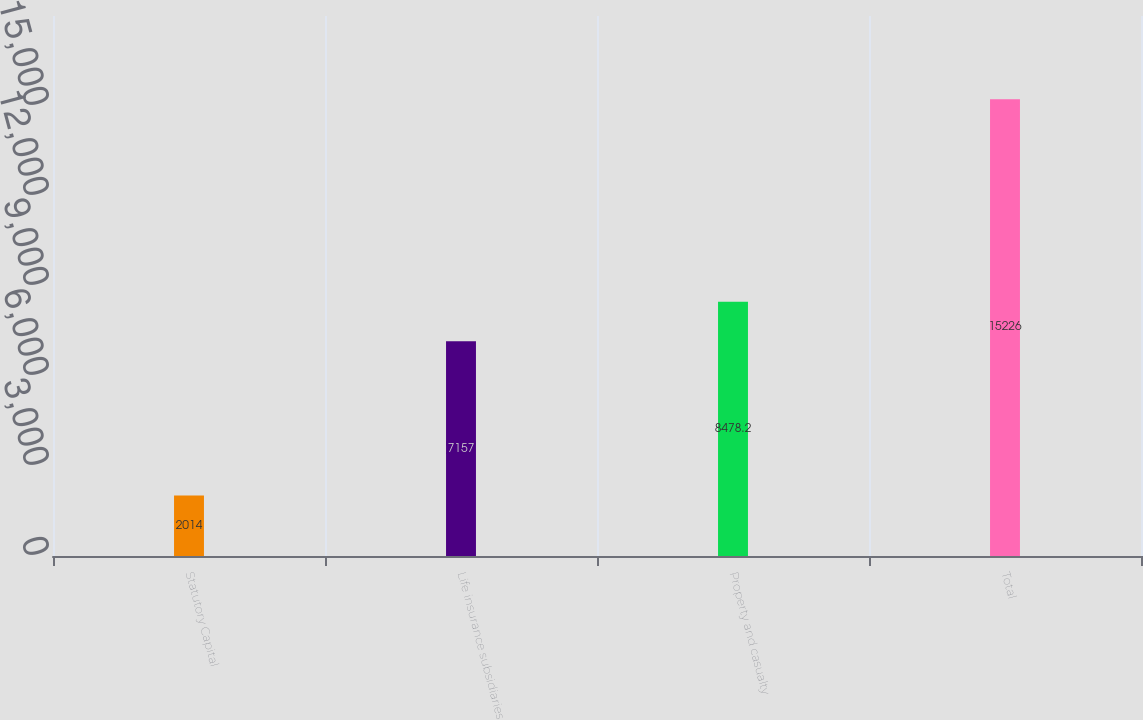<chart> <loc_0><loc_0><loc_500><loc_500><bar_chart><fcel>Statutory Capital<fcel>Life insurance subsidiaries<fcel>Property and casualty<fcel>Total<nl><fcel>2014<fcel>7157<fcel>8478.2<fcel>15226<nl></chart> 